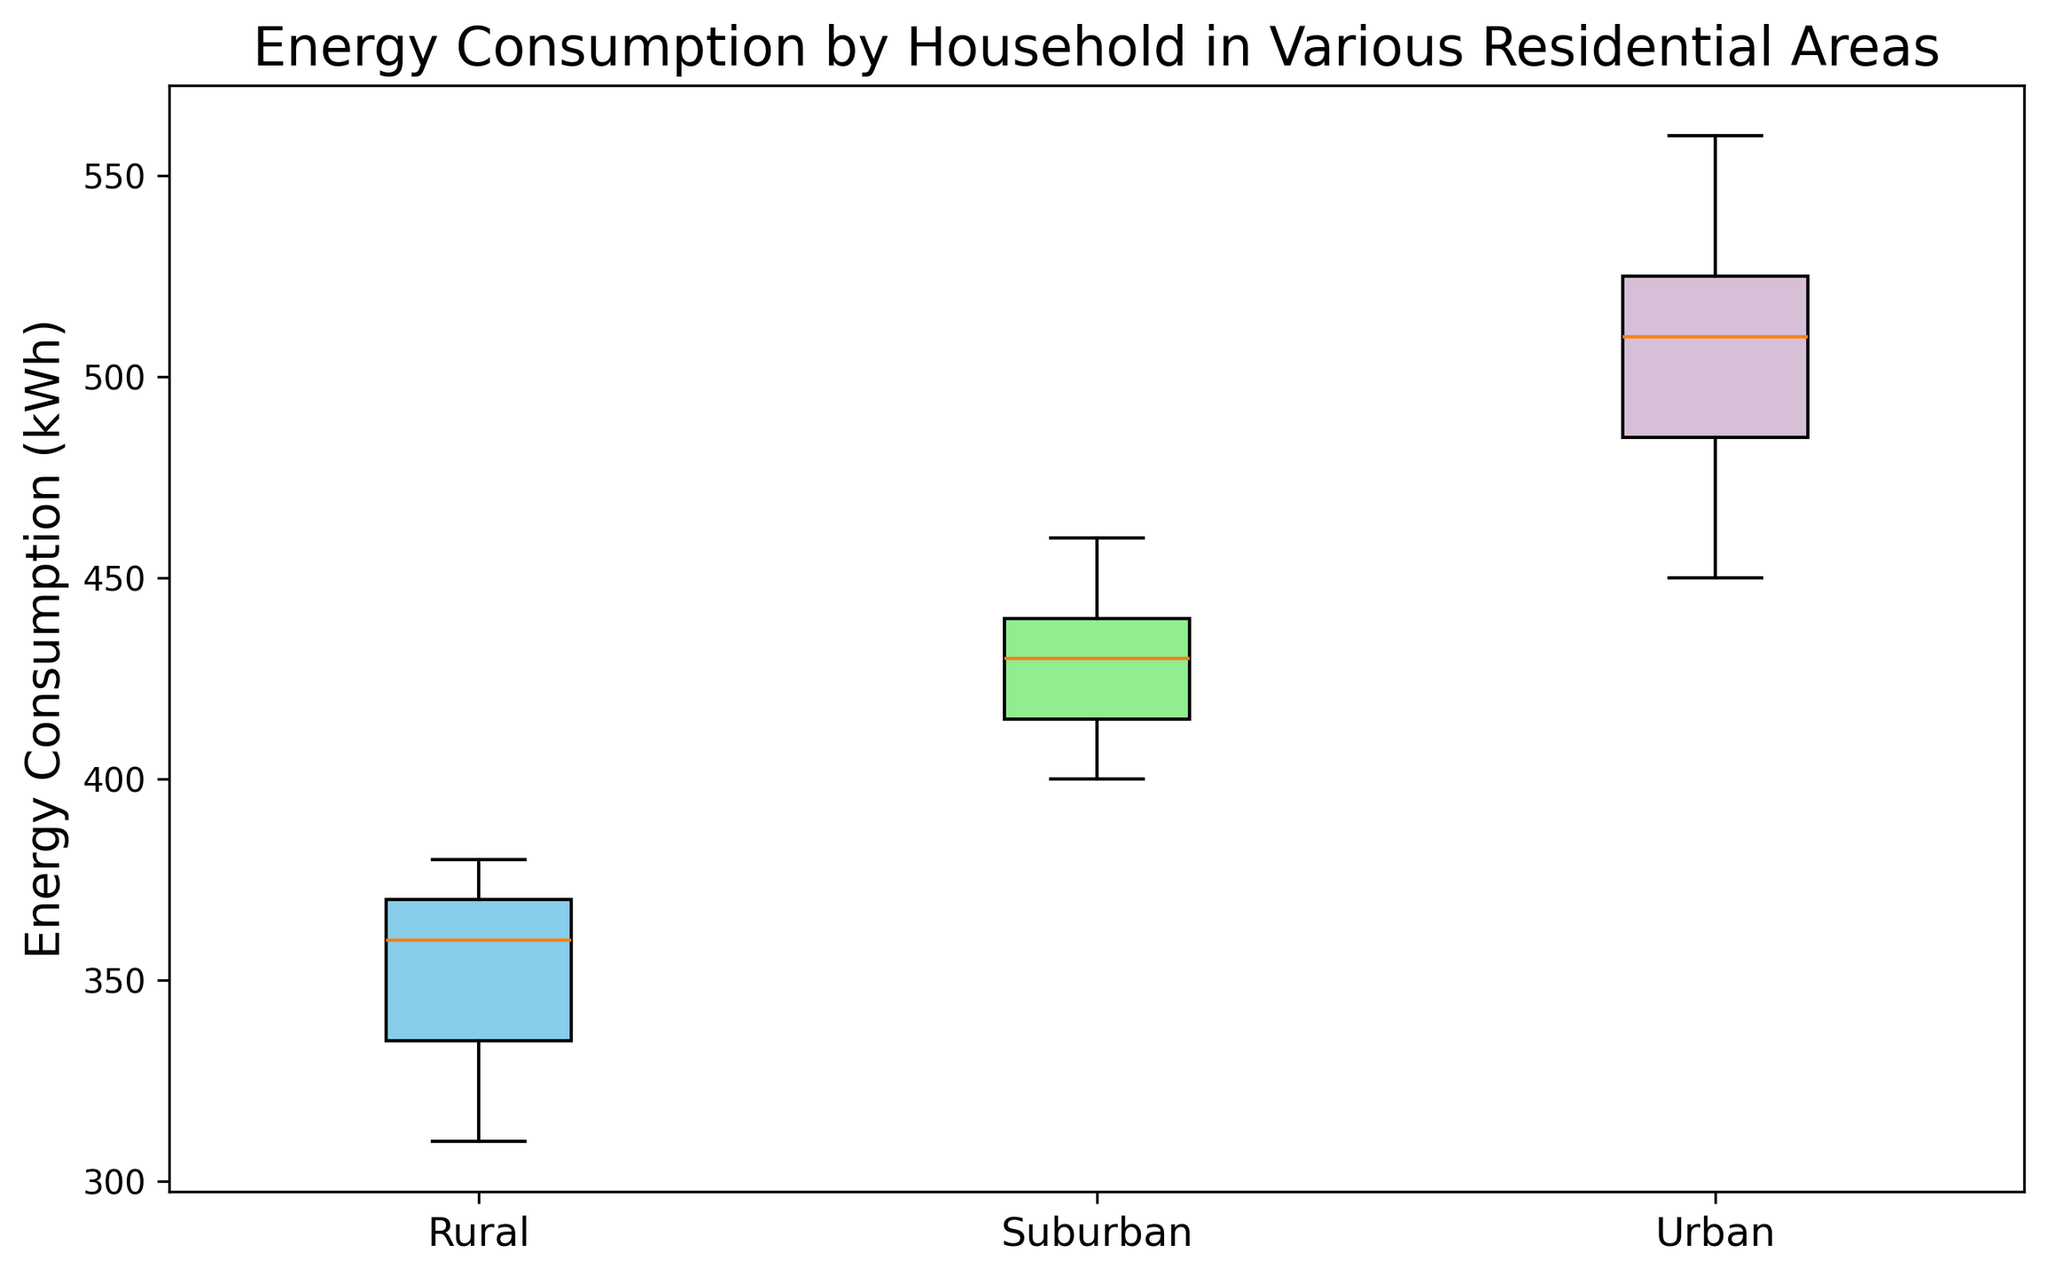What is the median energy consumption for Urban areas? The median is the middle value in a list of numbers. When the Urban energy consumption values are ordered (450, 470, 480, 490, 500, 510, 520, 520, 530, 540, 560), the median value is the middle one. So for an odd number of values, it's the average of the sixth and seventh values (510 + 520)/2.
Answer: 515 Which residential area has the highest median energy consumption? Comparing the medians of Urban, Suburban, and Rural areas, we see Urban has its median at 515, Suburban at 430, and Rural at 360. Therefore, Urban has the highest median energy consumption.
Answer: Urban Is there a significant difference in the range of energy consumption between Urban and Rural areas? The range is the difference between the maximum and minimum values. For Urban, the range is 560 - 450 = 110. For Rural, the range is 380 - 310 = 70. The Urban area has a larger range than the Rural area by 40 units.
Answer: Yes Which residential area shows the most variability in energy consumption? Variability can be inferred from the width of the boxes. Urban has the widest box, indicating it has the most variability.
Answer: Urban What is the color of the box that represents Suburban areas? The box representing Suburban areas is colored in light green.
Answer: Light green Based on the figure, which residential area has the smallest interquartile range (IQR)? The IQR is the difference between the first and third quartile. By looking at the heights of the colored boxes representing Q1 to Q3, Rural seems to have the smallest IQR.
Answer: Rural Is the median energy consumption of Suburban areas greater than or equal to the maximum energy consumption in Rural areas? The median energy consumption of Suburban areas is 430. The maximum energy consumption in Rural areas is 380. 430 is greater than 380.
Answer: Yes How many individual outliers are present overall across all residential areas? Looking at the red markers, there are a total of 0 outliers shown across all residential areas.
Answer: 0 If you sum the medians of energy consumption for all three residential areas, what is the total? The medians are 515 (Urban), 430 (Suburban), and 360 (Rural). Summing these gives 515 + 430 + 360 = 1305.
Answer: 1305 